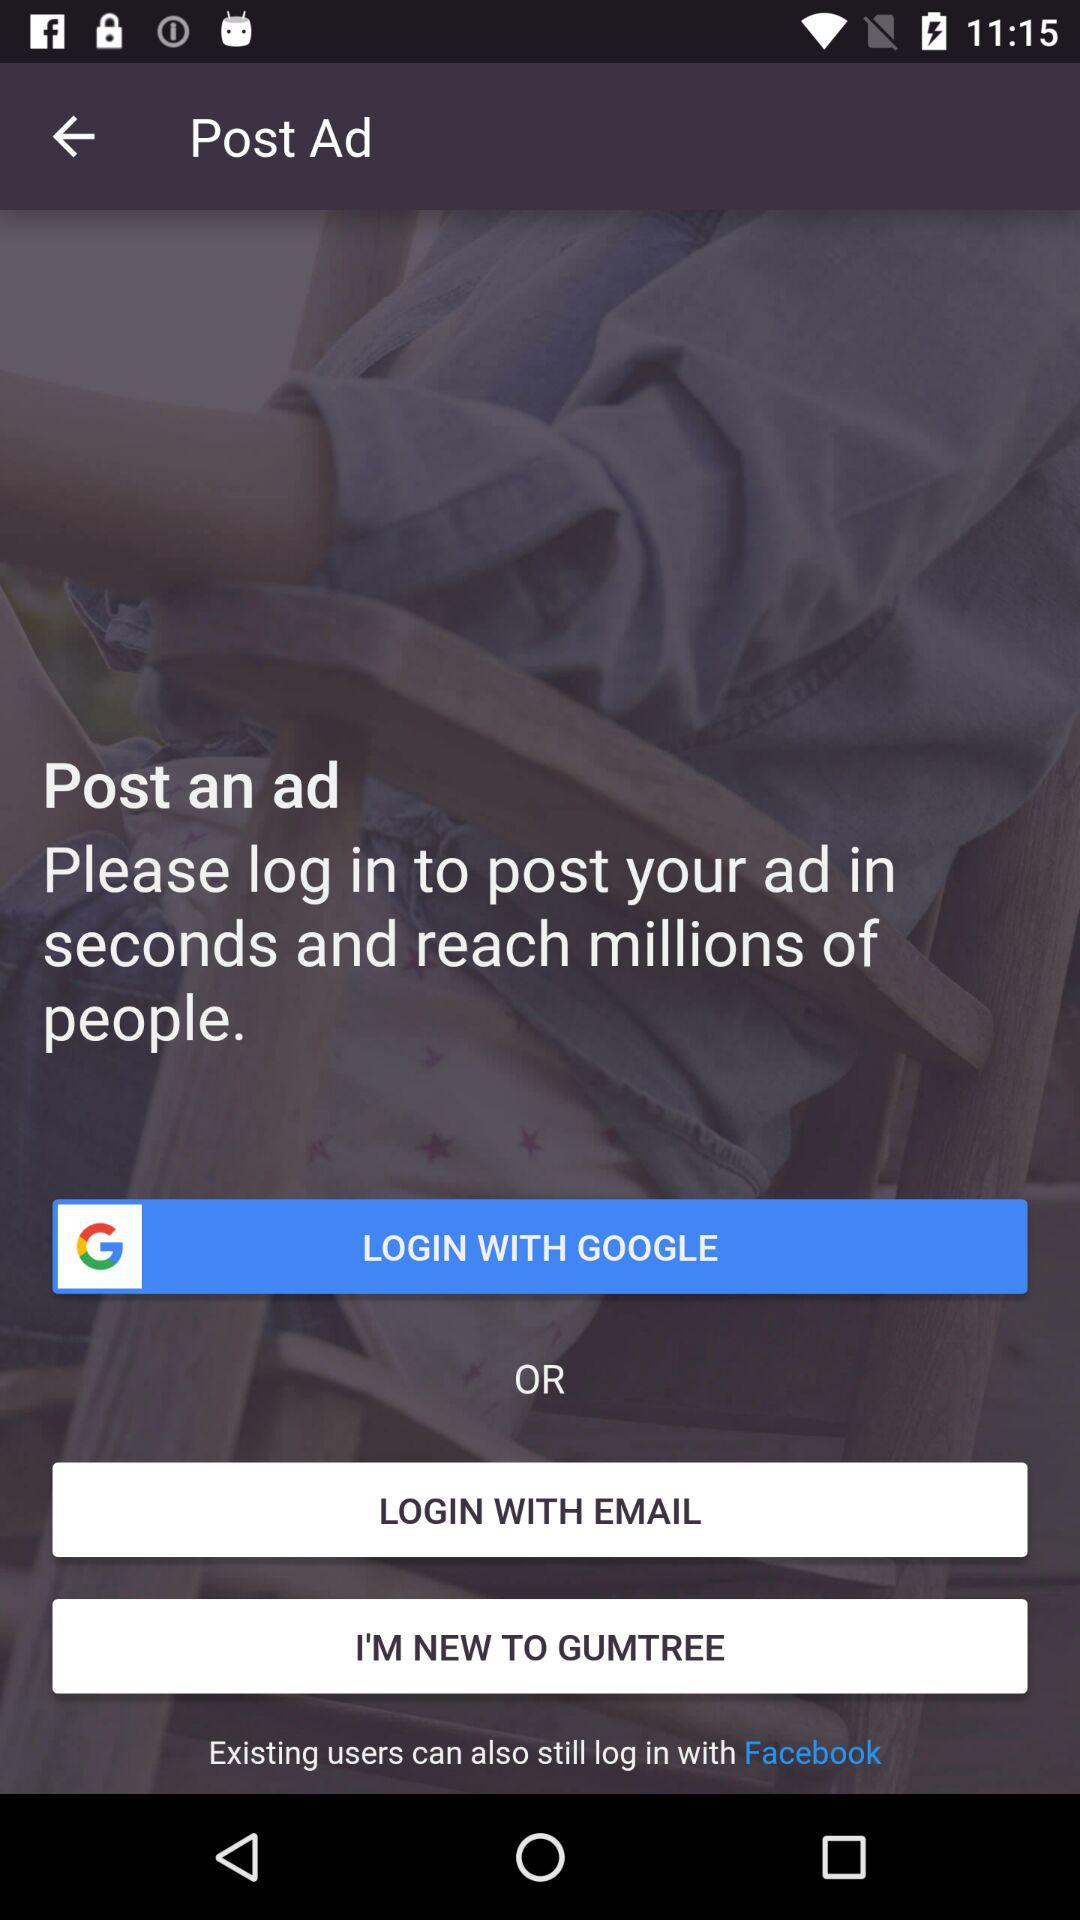What should I do to post an advertisement? To post an advertisement, you should log in. 